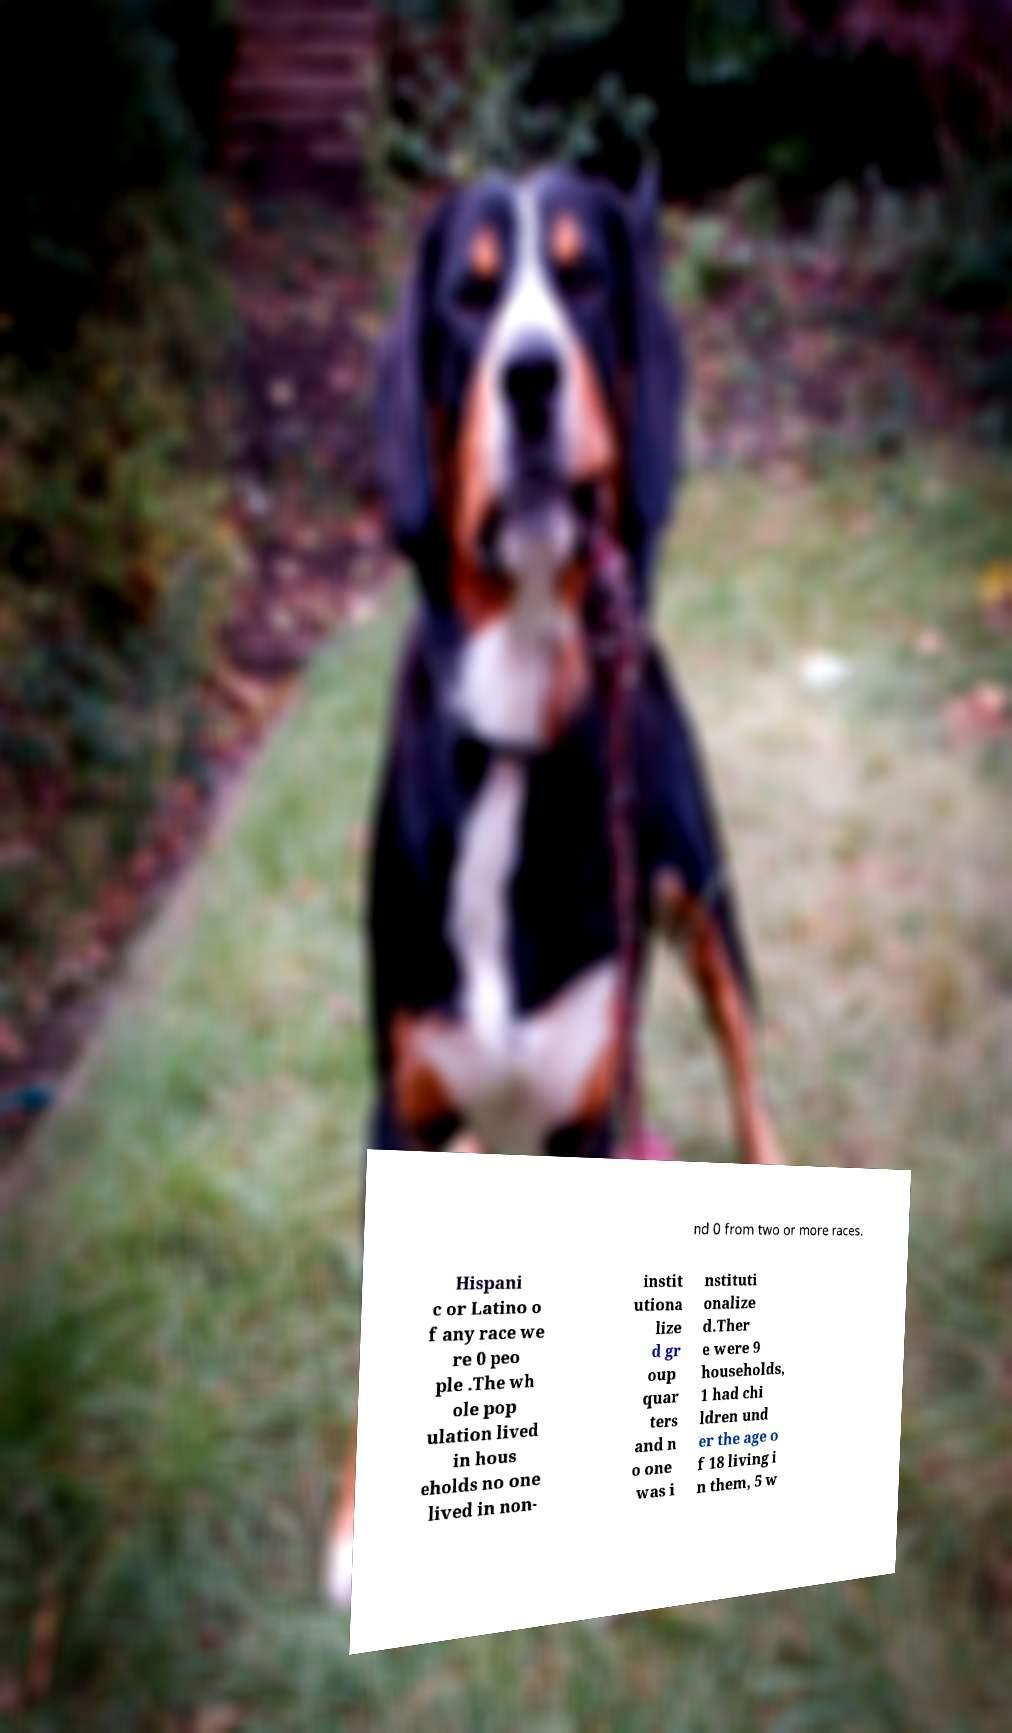Could you extract and type out the text from this image? nd 0 from two or more races. Hispani c or Latino o f any race we re 0 peo ple .The wh ole pop ulation lived in hous eholds no one lived in non- instit utiona lize d gr oup quar ters and n o one was i nstituti onalize d.Ther e were 9 households, 1 had chi ldren und er the age o f 18 living i n them, 5 w 